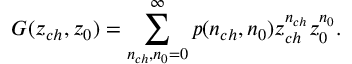<formula> <loc_0><loc_0><loc_500><loc_500>G ( z _ { c h } , z _ { 0 } ) = \sum _ { n _ { c h } , n _ { 0 } = 0 } ^ { \infty } p ( n _ { c h } , n _ { 0 } ) z _ { c h } ^ { n _ { c h } } z _ { 0 } ^ { n _ { 0 } } .</formula> 